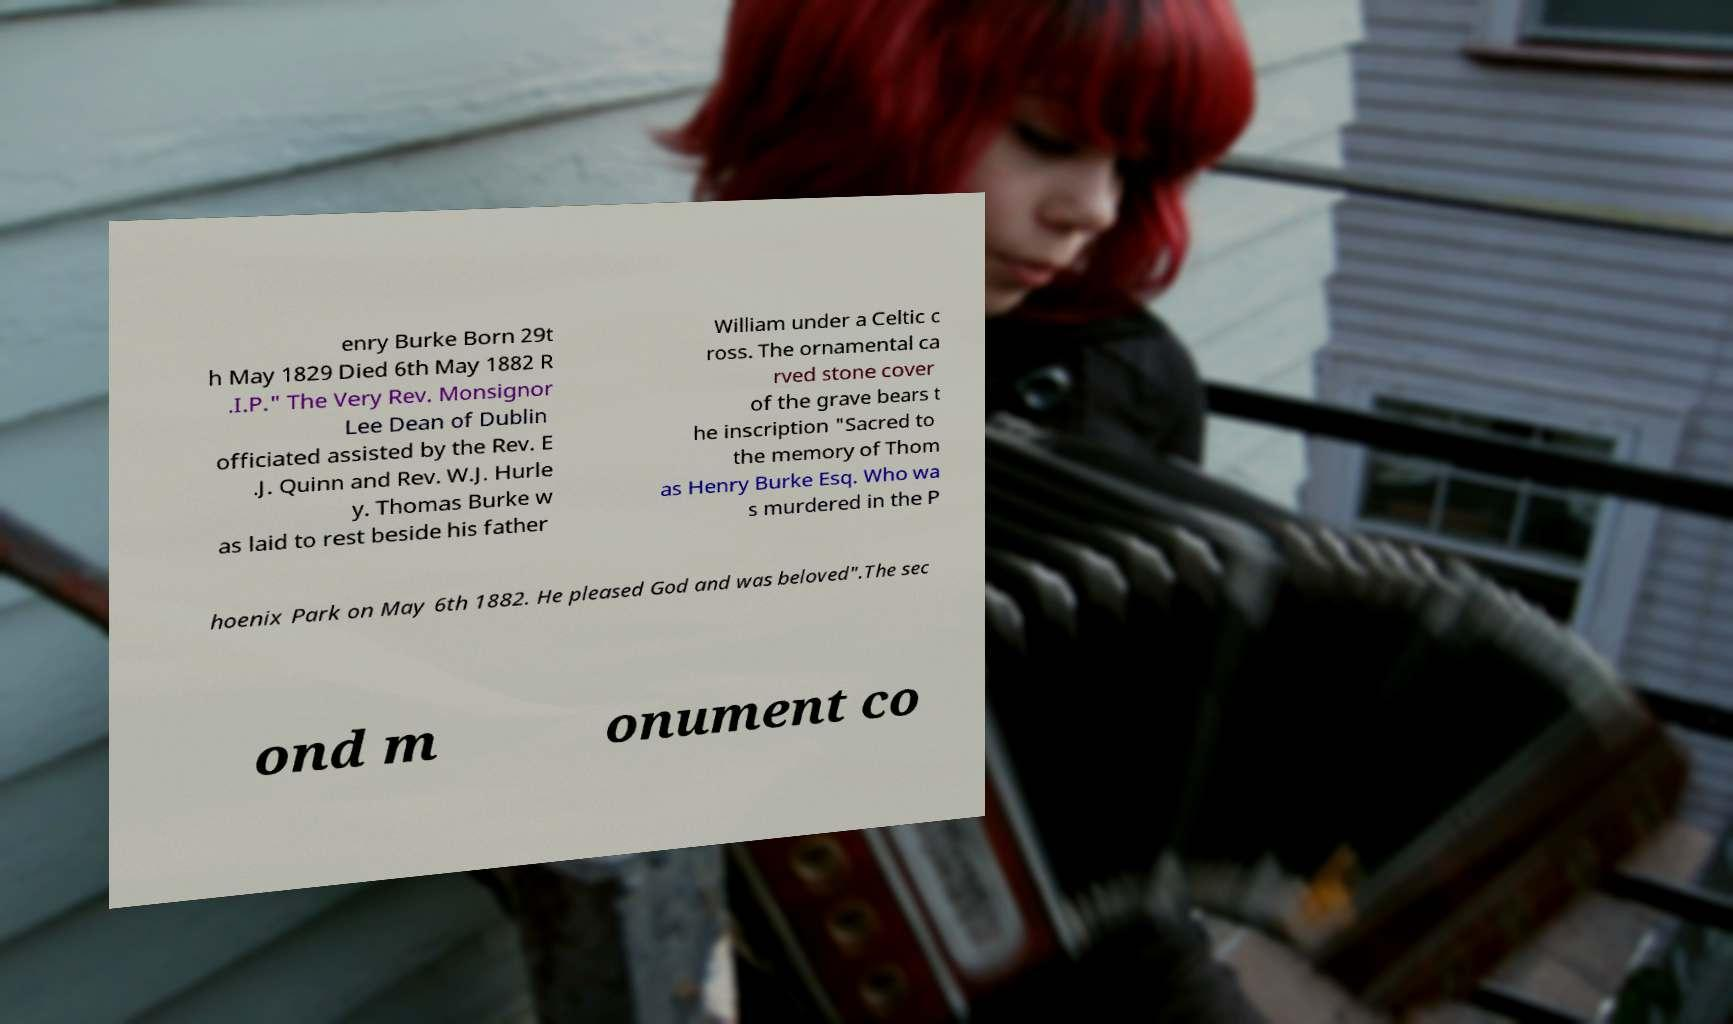Could you assist in decoding the text presented in this image and type it out clearly? enry Burke Born 29t h May 1829 Died 6th May 1882 R .I.P." The Very Rev. Monsignor Lee Dean of Dublin officiated assisted by the Rev. E .J. Quinn and Rev. W.J. Hurle y. Thomas Burke w as laid to rest beside his father William under a Celtic c ross. The ornamental ca rved stone cover of the grave bears t he inscription "Sacred to the memory of Thom as Henry Burke Esq. Who wa s murdered in the P hoenix Park on May 6th 1882. He pleased God and was beloved".The sec ond m onument co 